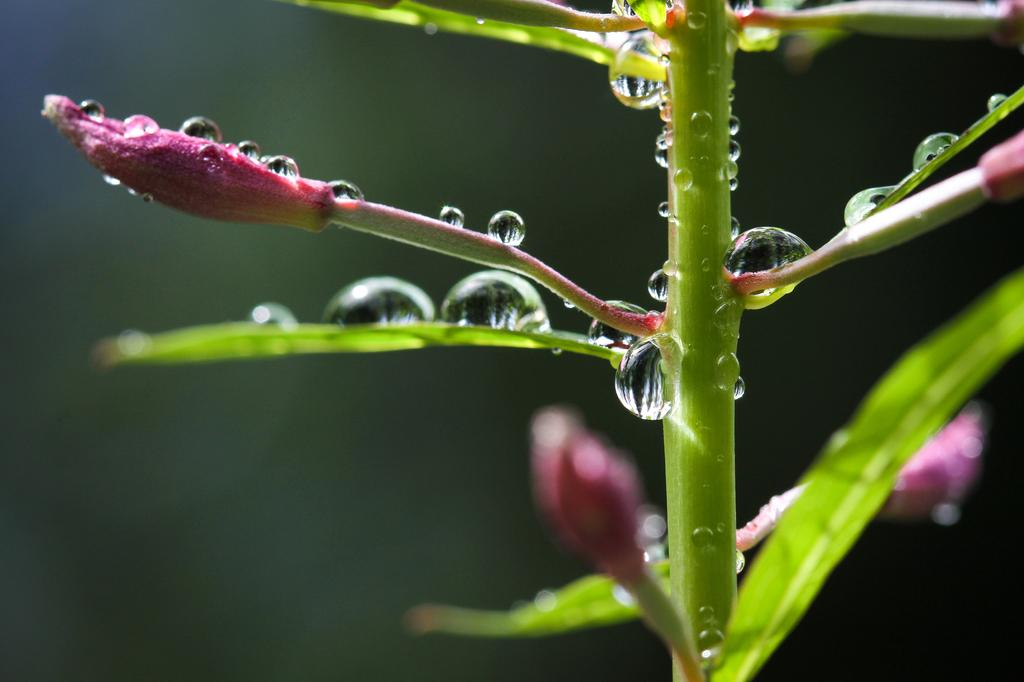What is the main subject of the image? The main subject of the image is a plant. Can you describe the condition of the plant? There are water drops on the plant. How would you describe the background of the image? The background of the image is blurred. How many sisters are depicted in the image? There are no sisters present in the image; it features a plant with water drops and a blurred background. 